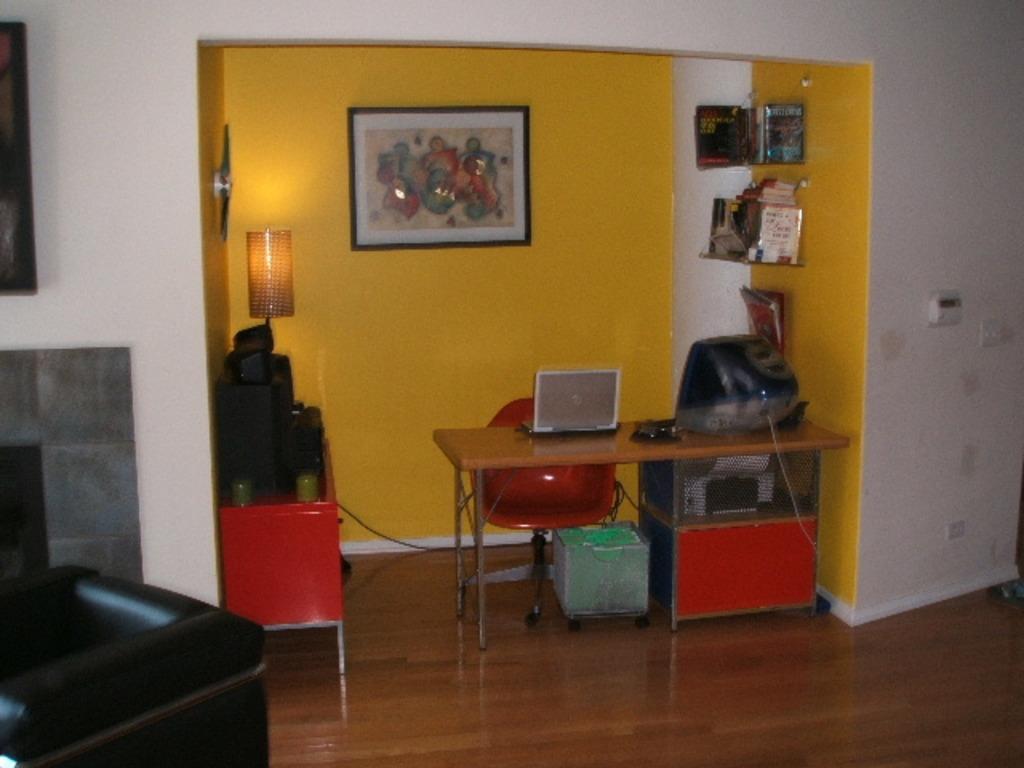Could you give a brief overview of what you see in this image? In this image we can see a table containing a laptop and a monitor on it. We can also see the chairs, wires, a trolley, some objects, glasses and a lamp placed on a table. We can also see the photo frames and switchboards on a wall and a group of books placed in the racks. 